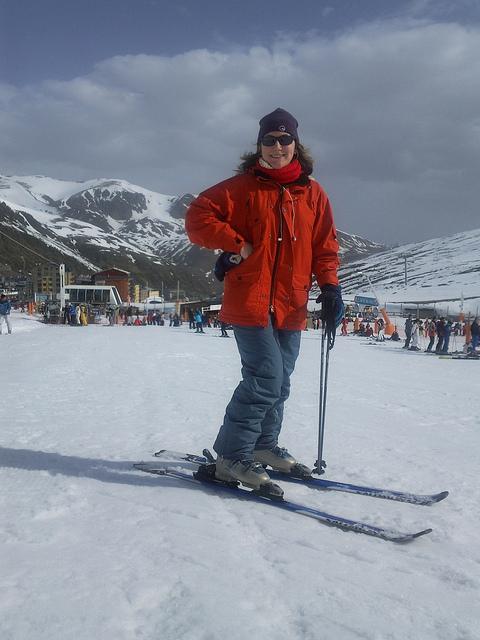What does the gesture the people are making mean?
Concise answer only. Posing. What color is the jacket?
Write a very short answer. Red. What is the man carrying in his hands?
Short answer required. Ski poles. Is the girl skiing?
Write a very short answer. Yes. Is this a child?
Quick response, please. No. Is this person wearing a hat?
Short answer required. Yes. What is the woman's hand?
Short answer required. Poles. Is there a long line of people waiting to ski?
Short answer required. Yes. Is this a man or a woman?
Concise answer only. Woman. Is the skier wearing goggles?
Answer briefly. Yes. What color pants is the woman wearing?
Concise answer only. Blue. How old is the woman in the picture?
Keep it brief. 35. What color is the woman's jacket?
Concise answer only. Red. Does the weather look clear?
Give a very brief answer. No. 